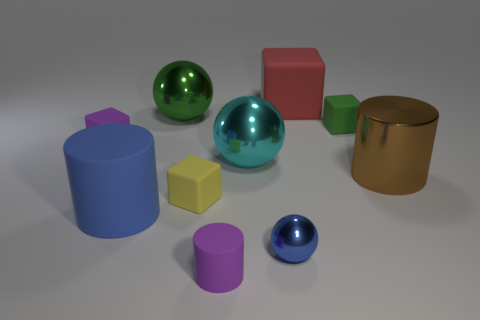What material is the green ball?
Your answer should be very brief. Metal. The green object that is the same size as the blue sphere is what shape?
Provide a short and direct response. Cube. Is there a rubber cylinder that has the same color as the small ball?
Keep it short and to the point. Yes. There is a small metal thing; does it have the same color as the cylinder that is left of the large green shiny ball?
Offer a terse response. Yes. There is a metal object behind the cube on the left side of the small yellow rubber block; what is its color?
Keep it short and to the point. Green. There is a shiny sphere left of the big metallic ball right of the green metal ball; are there any large cylinders on the right side of it?
Keep it short and to the point. Yes. The small cylinder that is made of the same material as the red cube is what color?
Provide a short and direct response. Purple. How many big red blocks are the same material as the blue cylinder?
Provide a short and direct response. 1. Are the yellow block and the purple object behind the tiny yellow cube made of the same material?
Give a very brief answer. Yes. What number of objects are either balls behind the tiny purple rubber block or tiny green metal objects?
Provide a succinct answer. 1. 